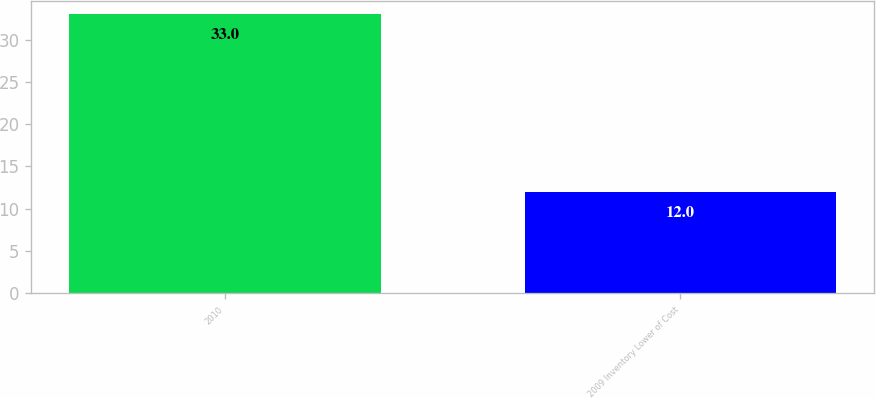Convert chart to OTSL. <chart><loc_0><loc_0><loc_500><loc_500><bar_chart><fcel>2010<fcel>2009 Inventory Lower of Cost<nl><fcel>33<fcel>12<nl></chart> 